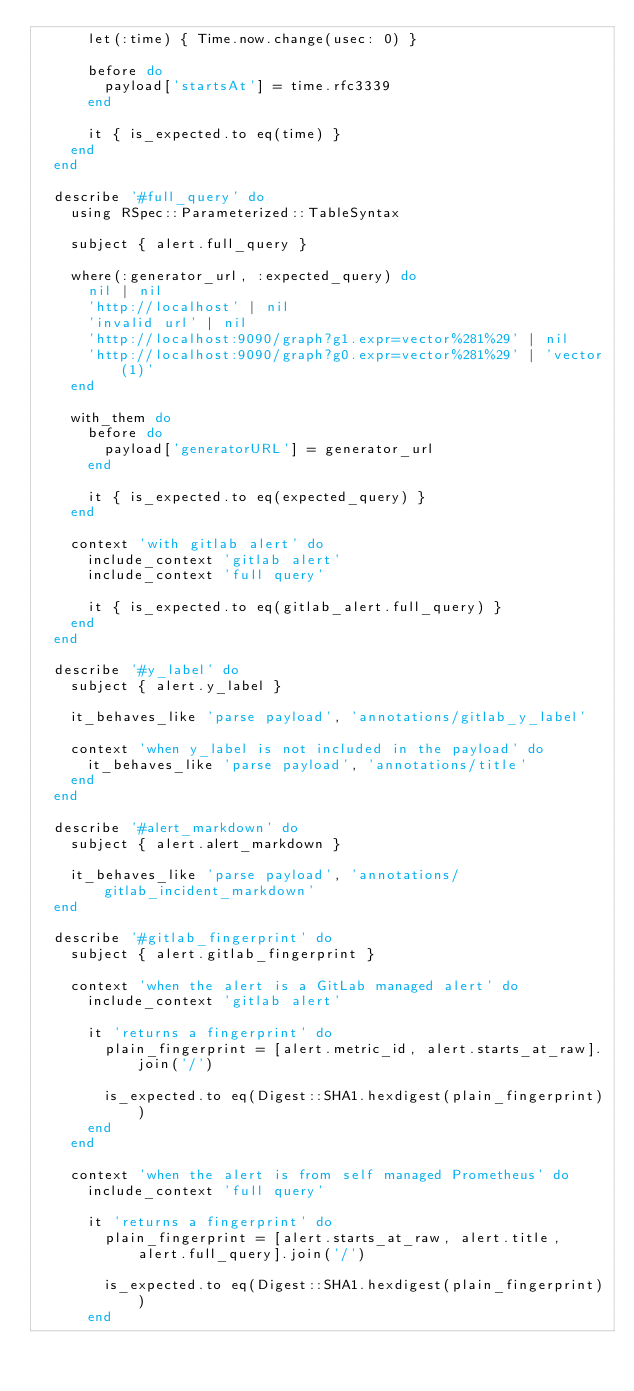<code> <loc_0><loc_0><loc_500><loc_500><_Ruby_>      let(:time) { Time.now.change(usec: 0) }

      before do
        payload['startsAt'] = time.rfc3339
      end

      it { is_expected.to eq(time) }
    end
  end

  describe '#full_query' do
    using RSpec::Parameterized::TableSyntax

    subject { alert.full_query }

    where(:generator_url, :expected_query) do
      nil | nil
      'http://localhost' | nil
      'invalid url' | nil
      'http://localhost:9090/graph?g1.expr=vector%281%29' | nil
      'http://localhost:9090/graph?g0.expr=vector%281%29' | 'vector(1)'
    end

    with_them do
      before do
        payload['generatorURL'] = generator_url
      end

      it { is_expected.to eq(expected_query) }
    end

    context 'with gitlab alert' do
      include_context 'gitlab alert'
      include_context 'full query'

      it { is_expected.to eq(gitlab_alert.full_query) }
    end
  end

  describe '#y_label' do
    subject { alert.y_label }

    it_behaves_like 'parse payload', 'annotations/gitlab_y_label'

    context 'when y_label is not included in the payload' do
      it_behaves_like 'parse payload', 'annotations/title'
    end
  end

  describe '#alert_markdown' do
    subject { alert.alert_markdown }

    it_behaves_like 'parse payload', 'annotations/gitlab_incident_markdown'
  end

  describe '#gitlab_fingerprint' do
    subject { alert.gitlab_fingerprint }

    context 'when the alert is a GitLab managed alert' do
      include_context 'gitlab alert'

      it 'returns a fingerprint' do
        plain_fingerprint = [alert.metric_id, alert.starts_at_raw].join('/')

        is_expected.to eq(Digest::SHA1.hexdigest(plain_fingerprint))
      end
    end

    context 'when the alert is from self managed Prometheus' do
      include_context 'full query'

      it 'returns a fingerprint' do
        plain_fingerprint = [alert.starts_at_raw, alert.title, alert.full_query].join('/')

        is_expected.to eq(Digest::SHA1.hexdigest(plain_fingerprint))
      end</code> 